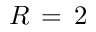<formula> <loc_0><loc_0><loc_500><loc_500>R \, = \, 2</formula> 